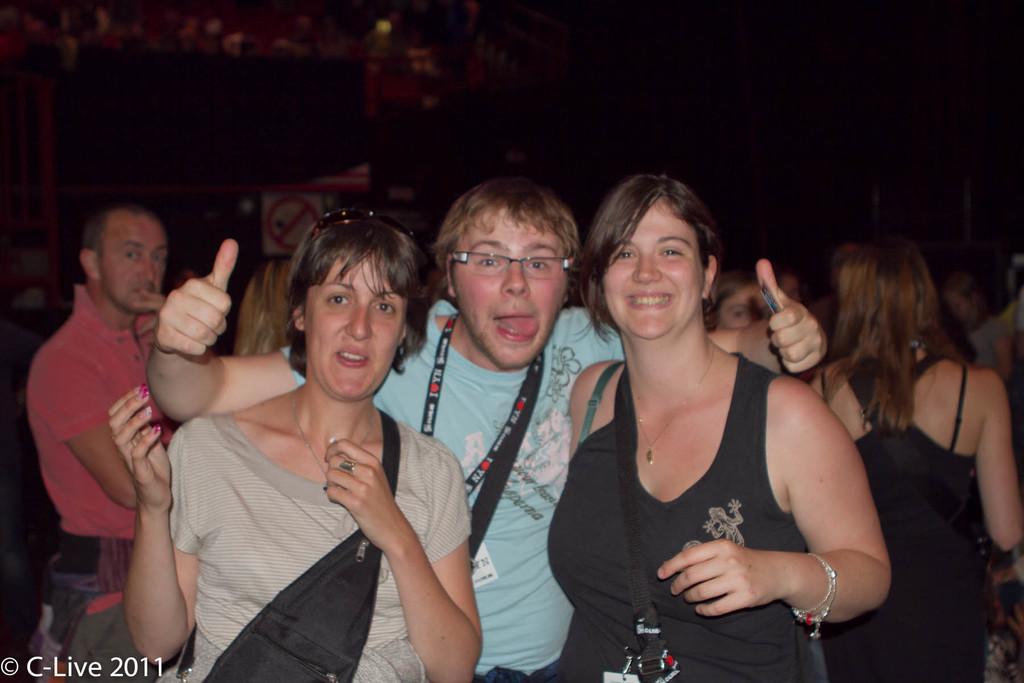In one or two sentences, can you explain what this image depicts? In this image I can see number of people are standing. In the front I can see one person is wearing specs. In the background I can see a sign board and on the bottom left side I can see a watermark. 